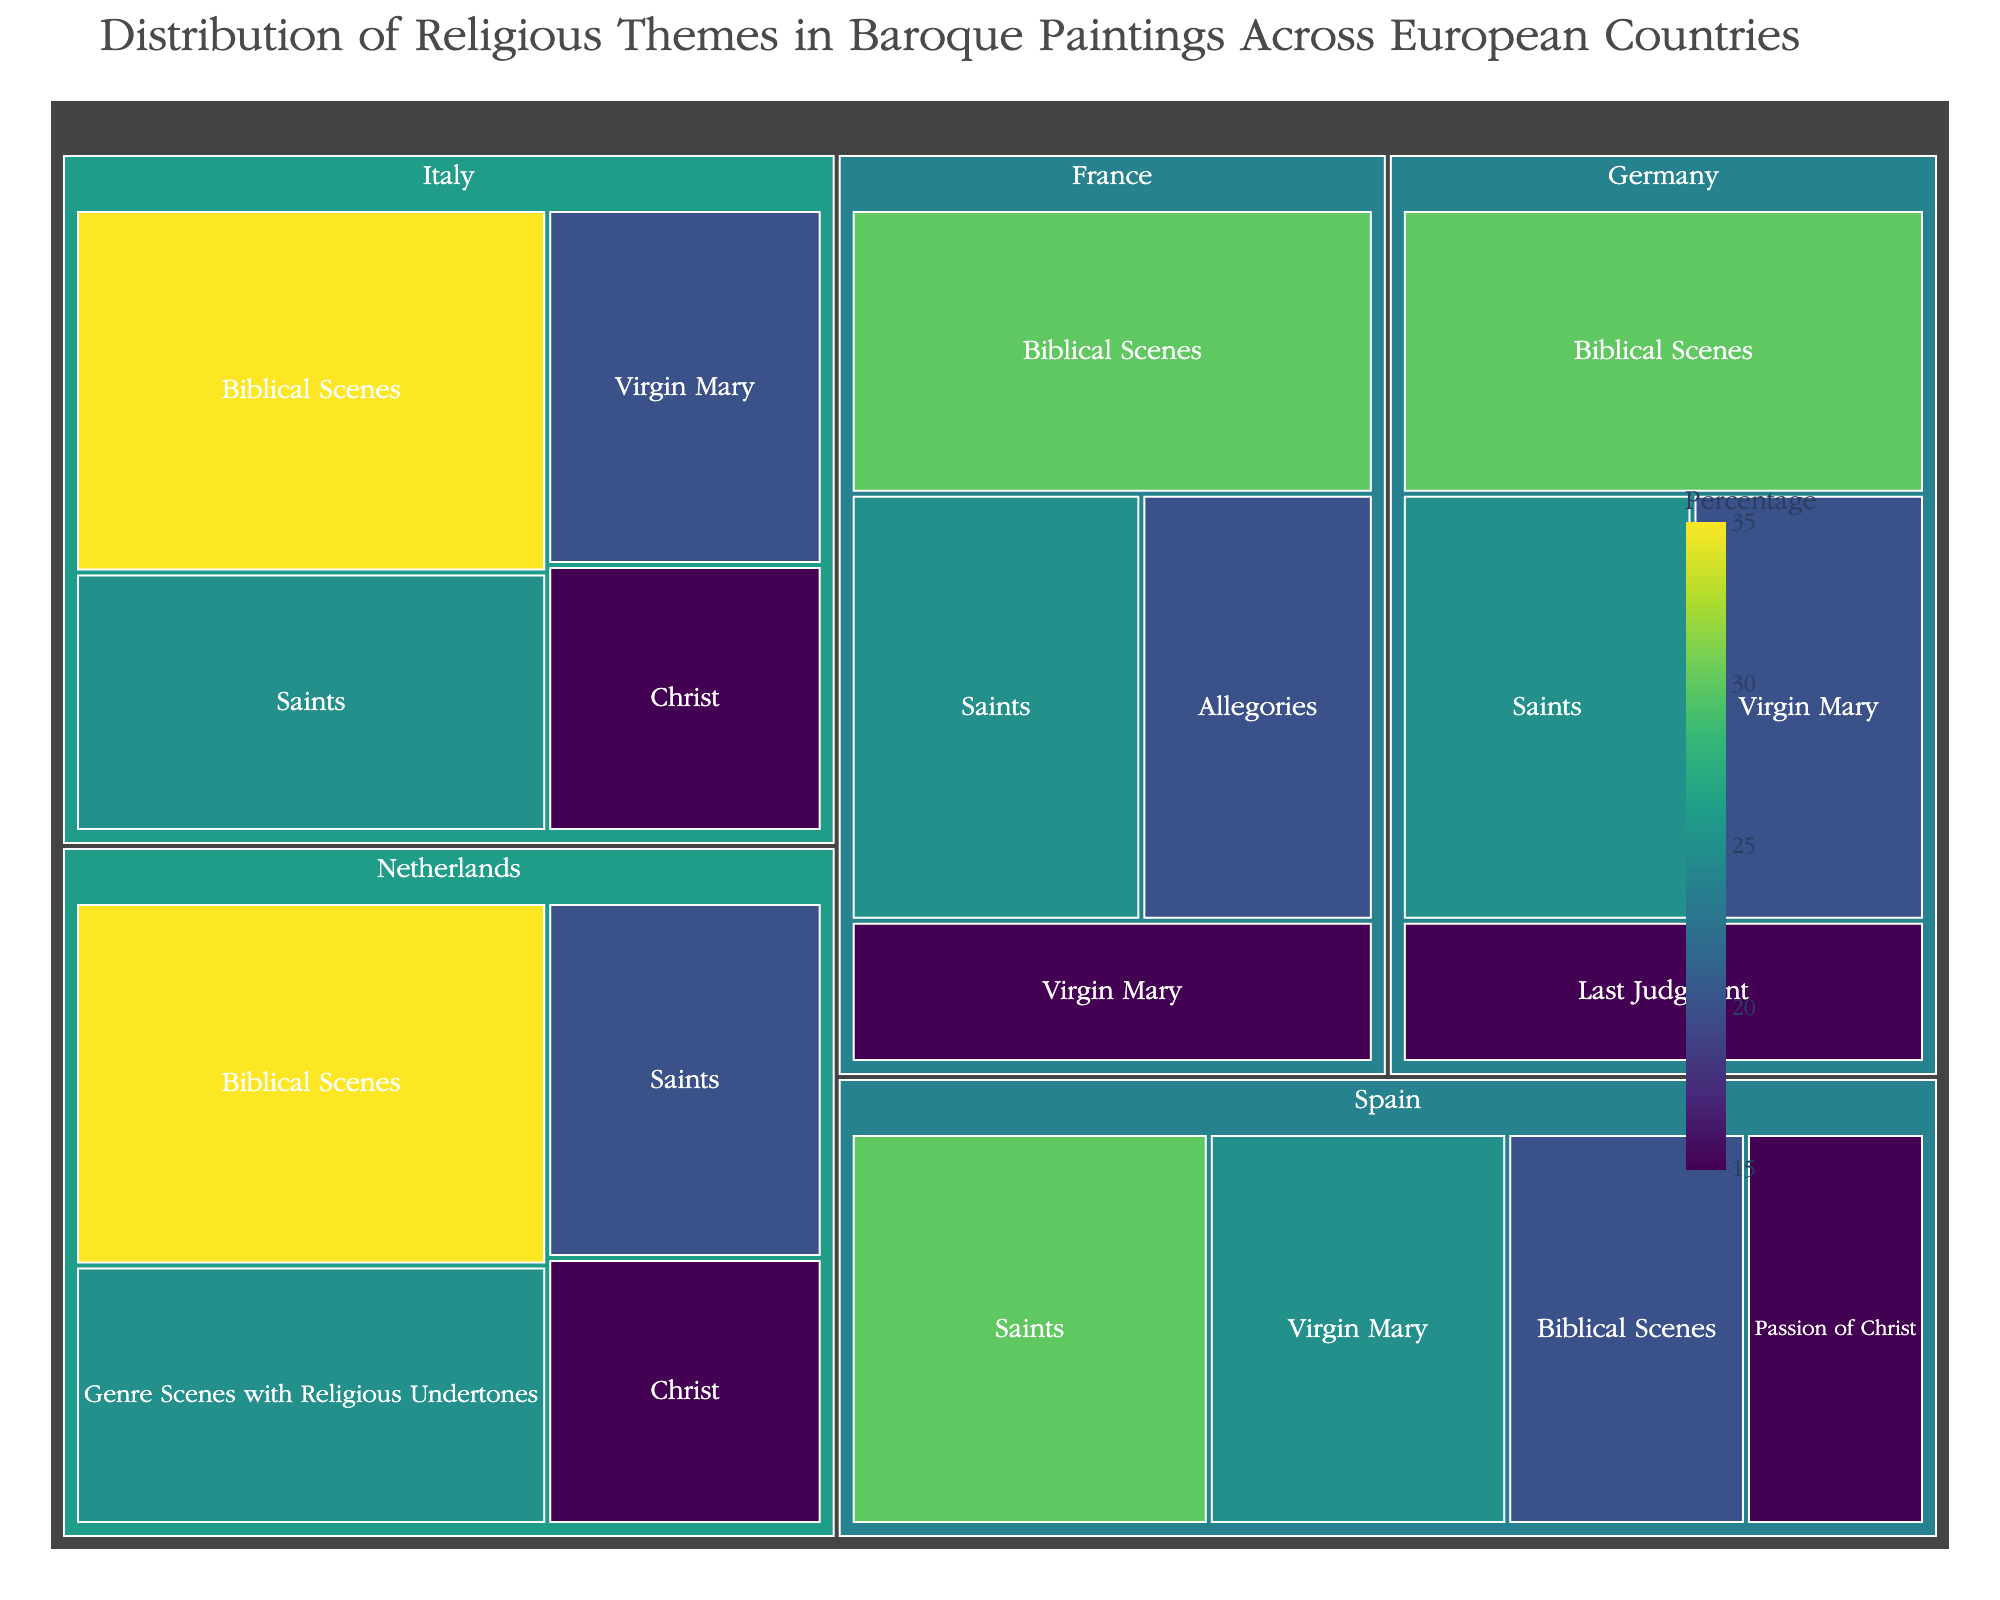What is the title of the treemap? The title is displayed at the top of the treemap and typically explains the focus of the visualization. Here, it should describe the overall theme and focus of the graph.
Answer: Distribution of Religious Themes in Baroque Paintings Across European Countries Which country has the highest percentage of paintings depicting Biblical Scenes? To find this information, look across the countries and identify which country has the largest segment for Biblical Scenes based on the numerical value or visual size.
Answer: Italy What is the total combined percentage of paintings depicting Saints from all countries? Add the percentages of the "Saints" theme from Italy (25%), Spain (30%), France (25%), Netherlands (20%), and Germany (25%). Summing these gives 125%.
Answer: 125% Which theme is most prevalent in paintings from the Netherlands? Identify the theme with the largest percentage in the Netherlands segment of the treemap.
Answer: Biblical Scenes What is the difference in percentage points between the Virgin Mary theme in Italy and Spain? Subtract the percentage of Virgin Mary paintings in Spain (25%) from that in Italy (20%).
Answer: 5% Which country has the most varied religious themes in terms of the number of distinct categories? Examine each country and count the number of different themes represented in their segments.
Answer: Netherlands and France (tied at 4 each) Between Italy and Germany, which country has a higher percentage of paintings depicting Christ? Compare the percentages of "Christ" paintings in Italy (15%) and Germany, recognizing that Germany doesn't list the "Christ" category, implying zero.
Answer: Italy Is the theme "Passion of Christ" depicted in more than one country? Look for the "Passion of Christ" theme and identify whether it appears under multiple country segments.
Answer: No How does the theme diversity in France compare to that in Spain? Count the number of distinct themes in the France segment (4) and the Spain segment (4), then compare them.
Answer: Equal What percentage of paintings in Germany's treemap segment are categorized under the Last Judgment theme? Locate the segment for Germany and identify the percentage assigned to the "Last Judgment" theme.
Answer: 15% 